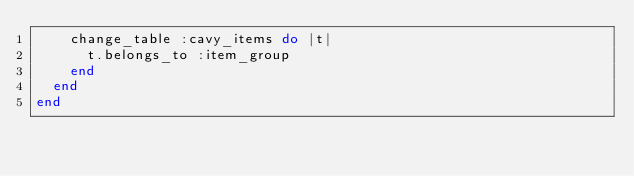<code> <loc_0><loc_0><loc_500><loc_500><_Ruby_>    change_table :cavy_items do |t|
      t.belongs_to :item_group
    end
  end
end
</code> 